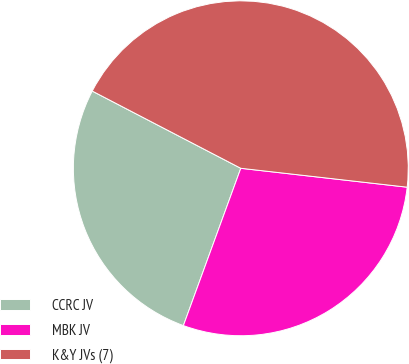Convert chart to OTSL. <chart><loc_0><loc_0><loc_500><loc_500><pie_chart><fcel>CCRC JV<fcel>MBK JV<fcel>K&Y JVs (7)<nl><fcel>27.06%<fcel>28.77%<fcel>44.17%<nl></chart> 